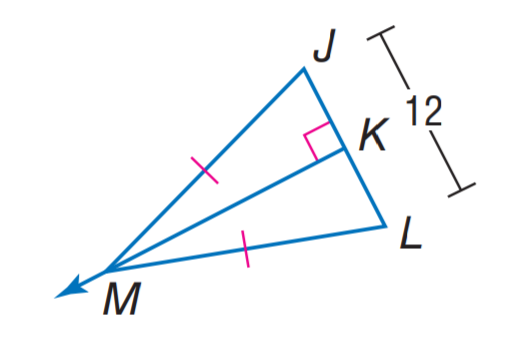Question: Find K L.
Choices:
A. 3
B. 6
C. 12
D. 18
Answer with the letter. Answer: B 